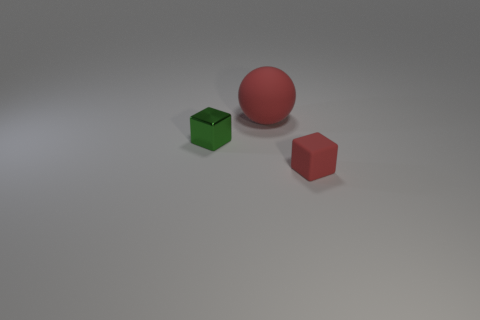There is a object that is the same color as the matte sphere; what shape is it?
Keep it short and to the point. Cube. What size is the rubber thing that is the same color as the small rubber block?
Ensure brevity in your answer.  Large. Do the block on the right side of the big red ball and the cube that is behind the small rubber object have the same size?
Ensure brevity in your answer.  Yes. There is a thing that is both on the right side of the small green shiny thing and in front of the big red sphere; what shape is it?
Make the answer very short. Cube. Are there any large things that have the same color as the ball?
Offer a very short reply. No. Are any gray matte things visible?
Your answer should be very brief. No. The tiny object behind the red block is what color?
Provide a succinct answer. Green. Do the metallic cube and the red thing that is right of the red rubber sphere have the same size?
Make the answer very short. Yes. How big is the object that is in front of the large ball and behind the red rubber cube?
Keep it short and to the point. Small. Are there any objects made of the same material as the red cube?
Give a very brief answer. Yes. 